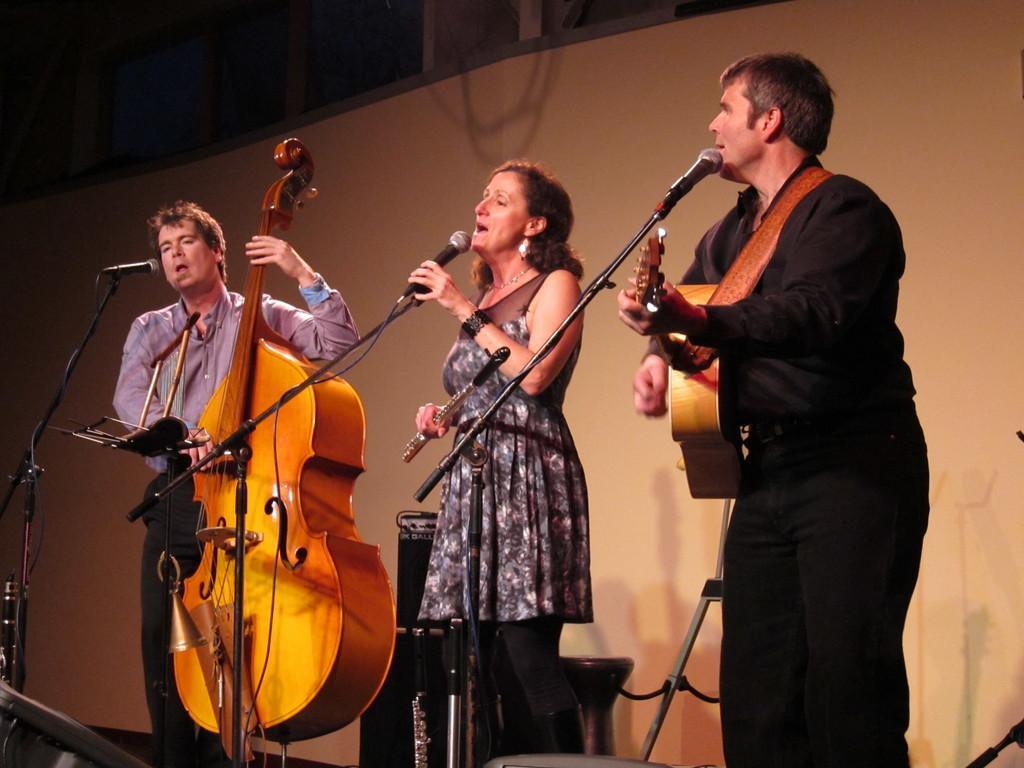How would you summarize this image in a sentence or two? In the image there are three people playing their musical instruments. In middle there is a woman holding a microphone and opened her mouth for singing. On left side there is another man playing his violin, on right side there is another man playing his guitar in background there is a wall which is in white color. 